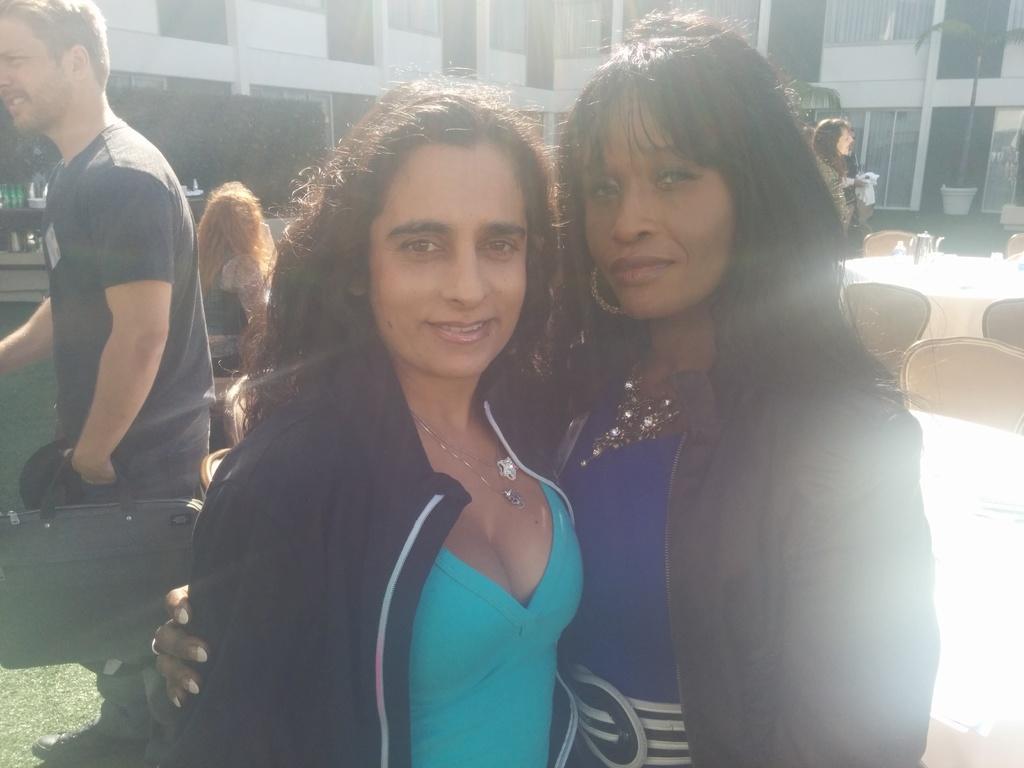Please provide a concise description of this image. This picture shows few people standing and we see chairs and a table and we see buildings and we see a man holding a bag in his hand. 